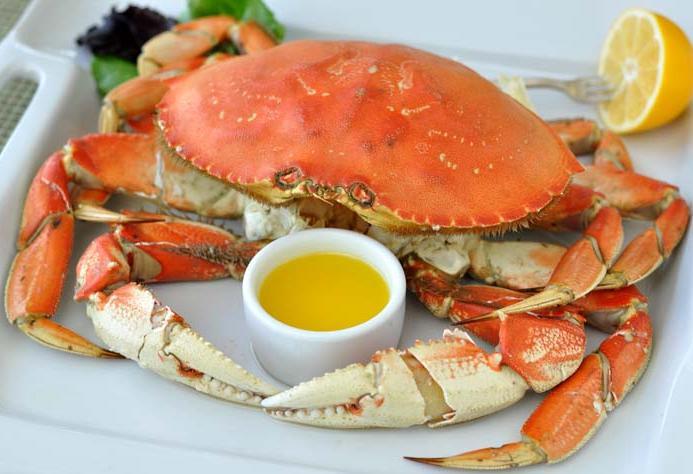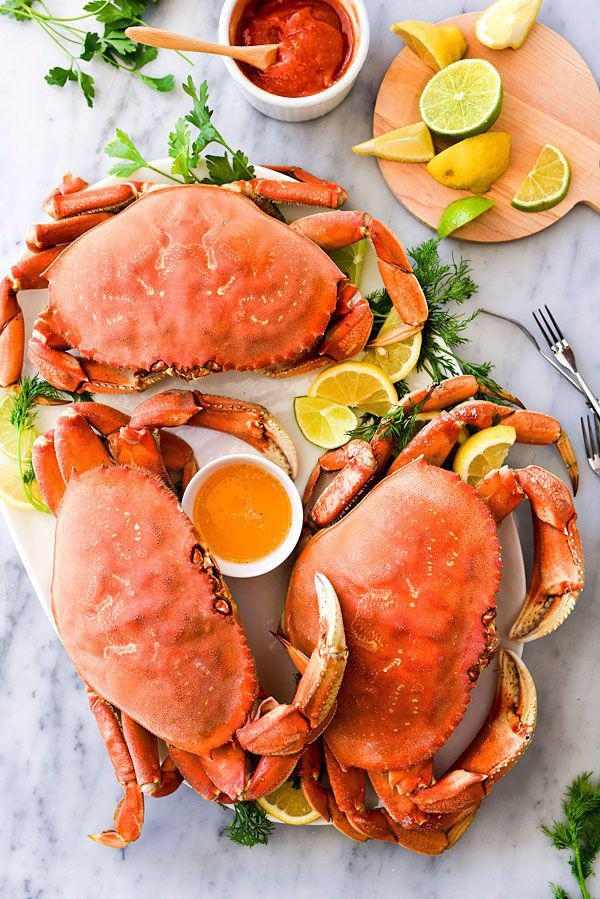The first image is the image on the left, the second image is the image on the right. Examine the images to the left and right. Is the description "At least one crab dish is served with a lemon next to the crab on the plate." accurate? Answer yes or no. Yes. The first image is the image on the left, the second image is the image on the right. Assess this claim about the two images: "In at least one image there is a cooked fullcrab facing left and forward.". Correct or not? Answer yes or no. Yes. 